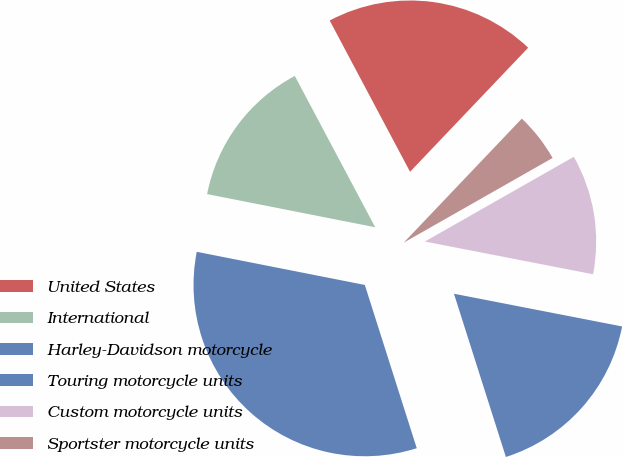Convert chart. <chart><loc_0><loc_0><loc_500><loc_500><pie_chart><fcel>United States<fcel>International<fcel>Harley-Davidson motorcycle<fcel>Touring motorcycle units<fcel>Custom motorcycle units<fcel>Sportster motorcycle units<nl><fcel>19.88%<fcel>14.13%<fcel>33.0%<fcel>17.04%<fcel>11.29%<fcel>4.66%<nl></chart> 